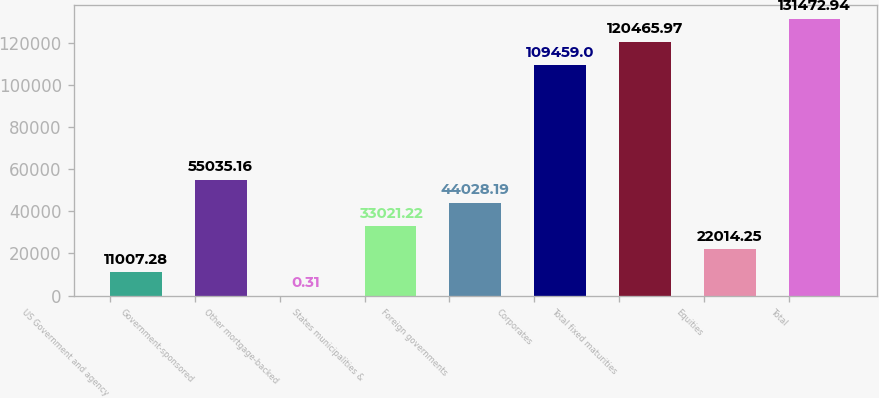Convert chart to OTSL. <chart><loc_0><loc_0><loc_500><loc_500><bar_chart><fcel>US Government and agency<fcel>Government-sponsored<fcel>Other mortgage-backed<fcel>States municipalities &<fcel>Foreign governments<fcel>Corporates<fcel>Total fixed maturities<fcel>Equities<fcel>Total<nl><fcel>11007.3<fcel>55035.2<fcel>0.31<fcel>33021.2<fcel>44028.2<fcel>109459<fcel>120466<fcel>22014.2<fcel>131473<nl></chart> 